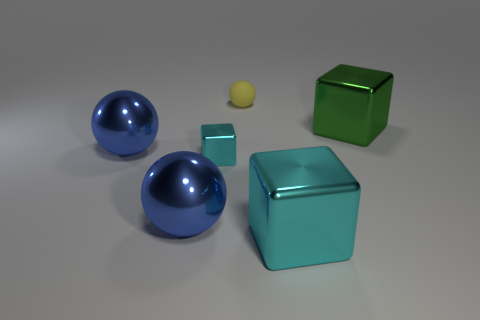Is there any other thing that is made of the same material as the tiny sphere?
Your answer should be very brief. No. Is the color of the tiny object left of the tiny matte object the same as the large block that is in front of the green block?
Your response must be concise. Yes. There is a small yellow rubber sphere; how many small cyan blocks are in front of it?
Your answer should be very brief. 1. Is there a cyan metal cube that is in front of the cyan metallic block in front of the cyan metal block that is to the left of the large cyan cube?
Give a very brief answer. No. How many metallic balls have the same size as the green block?
Ensure brevity in your answer.  2. There is a large blue sphere behind the cyan metallic block to the left of the yellow rubber thing; what is it made of?
Offer a very short reply. Metal. The large thing to the right of the cyan shiny thing that is on the right side of the cyan metallic block that is on the left side of the yellow ball is what shape?
Give a very brief answer. Cube. There is a thing behind the large green metal cube; does it have the same shape as the small thing in front of the big green metal cube?
Offer a very short reply. No. How many other objects are the same material as the small cyan thing?
Make the answer very short. 4. What is the shape of the tiny cyan object that is the same material as the big cyan cube?
Offer a very short reply. Cube. 